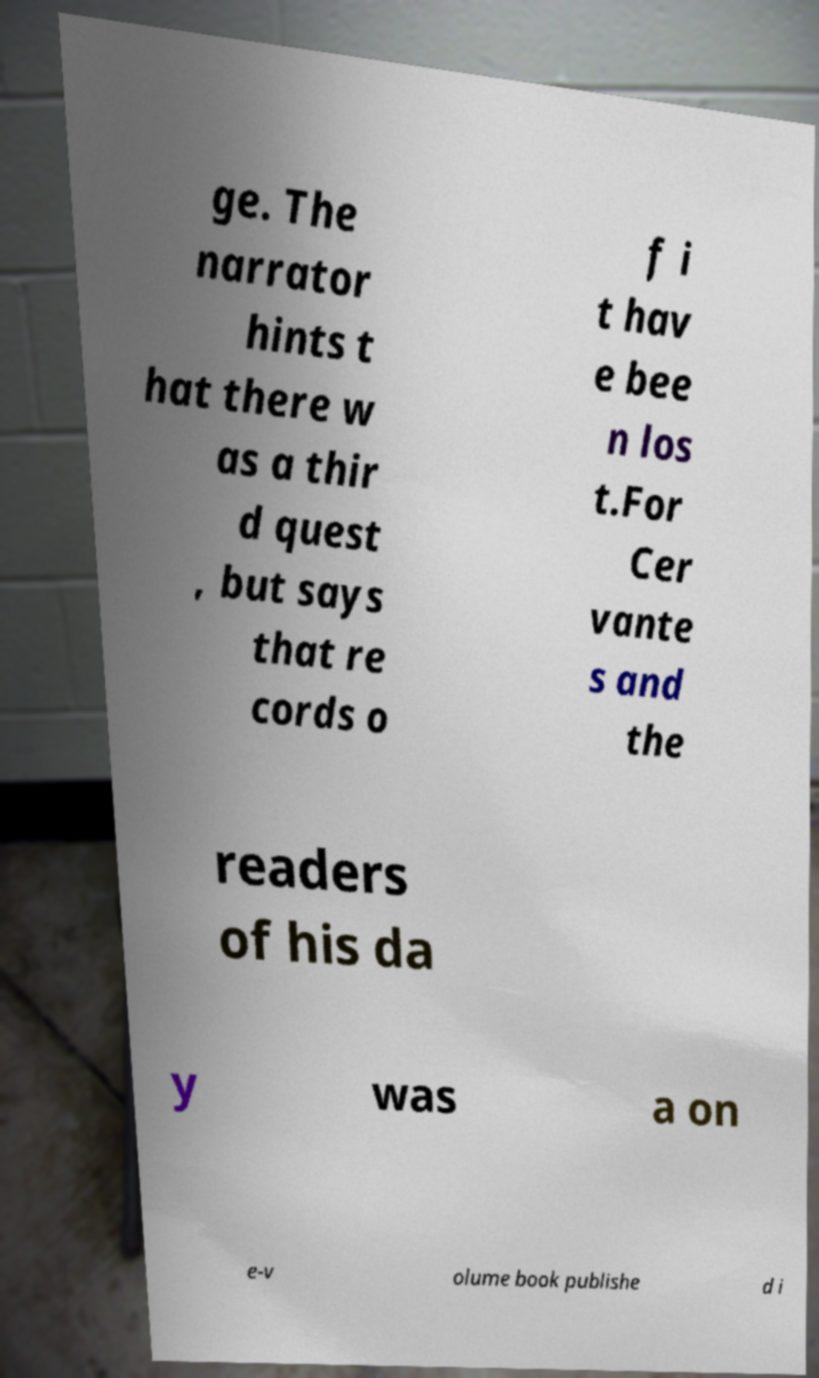There's text embedded in this image that I need extracted. Can you transcribe it verbatim? ge. The narrator hints t hat there w as a thir d quest , but says that re cords o f i t hav e bee n los t.For Cer vante s and the readers of his da y was a on e-v olume book publishe d i 